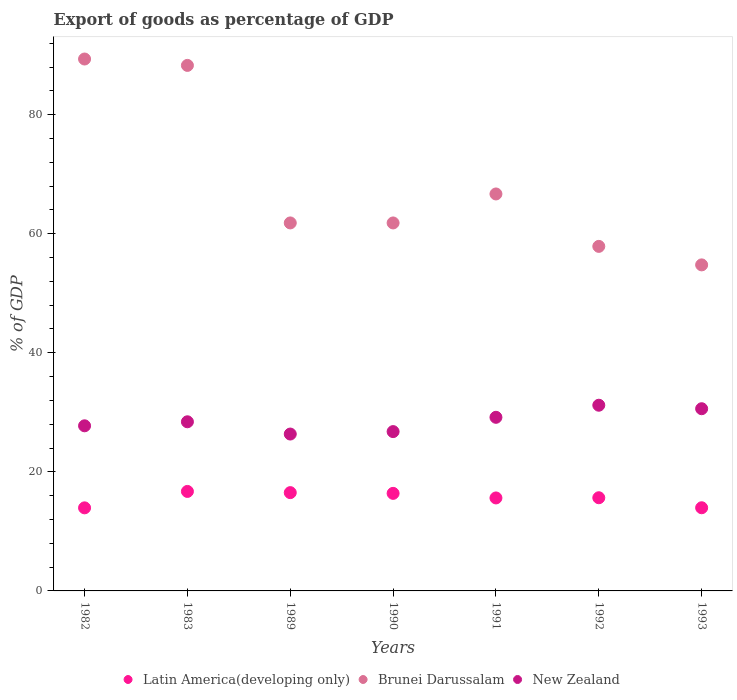Is the number of dotlines equal to the number of legend labels?
Make the answer very short. Yes. What is the export of goods as percentage of GDP in Latin America(developing only) in 1991?
Offer a very short reply. 15.62. Across all years, what is the maximum export of goods as percentage of GDP in New Zealand?
Make the answer very short. 31.19. Across all years, what is the minimum export of goods as percentage of GDP in Latin America(developing only)?
Offer a very short reply. 13.95. In which year was the export of goods as percentage of GDP in Latin America(developing only) maximum?
Provide a short and direct response. 1983. In which year was the export of goods as percentage of GDP in Latin America(developing only) minimum?
Give a very brief answer. 1982. What is the total export of goods as percentage of GDP in New Zealand in the graph?
Give a very brief answer. 200.21. What is the difference between the export of goods as percentage of GDP in Brunei Darussalam in 1989 and that in 1991?
Offer a very short reply. -4.87. What is the difference between the export of goods as percentage of GDP in New Zealand in 1989 and the export of goods as percentage of GDP in Latin America(developing only) in 1982?
Ensure brevity in your answer.  12.4. What is the average export of goods as percentage of GDP in New Zealand per year?
Give a very brief answer. 28.6. In the year 1992, what is the difference between the export of goods as percentage of GDP in Latin America(developing only) and export of goods as percentage of GDP in Brunei Darussalam?
Provide a succinct answer. -42.22. What is the ratio of the export of goods as percentage of GDP in Latin America(developing only) in 1983 to that in 1993?
Offer a very short reply. 1.2. Is the difference between the export of goods as percentage of GDP in Latin America(developing only) in 1983 and 1990 greater than the difference between the export of goods as percentage of GDP in Brunei Darussalam in 1983 and 1990?
Offer a very short reply. No. What is the difference between the highest and the second highest export of goods as percentage of GDP in New Zealand?
Make the answer very short. 0.59. What is the difference between the highest and the lowest export of goods as percentage of GDP in Brunei Darussalam?
Keep it short and to the point. 34.58. In how many years, is the export of goods as percentage of GDP in Brunei Darussalam greater than the average export of goods as percentage of GDP in Brunei Darussalam taken over all years?
Provide a succinct answer. 2. Is it the case that in every year, the sum of the export of goods as percentage of GDP in Latin America(developing only) and export of goods as percentage of GDP in Brunei Darussalam  is greater than the export of goods as percentage of GDP in New Zealand?
Ensure brevity in your answer.  Yes. Is the export of goods as percentage of GDP in Brunei Darussalam strictly greater than the export of goods as percentage of GDP in New Zealand over the years?
Your response must be concise. Yes. Is the export of goods as percentage of GDP in Latin America(developing only) strictly less than the export of goods as percentage of GDP in New Zealand over the years?
Offer a very short reply. Yes. Are the values on the major ticks of Y-axis written in scientific E-notation?
Your answer should be compact. No. Does the graph contain any zero values?
Provide a short and direct response. No. Does the graph contain grids?
Your answer should be very brief. No. How many legend labels are there?
Give a very brief answer. 3. What is the title of the graph?
Your answer should be very brief. Export of goods as percentage of GDP. Does "West Bank and Gaza" appear as one of the legend labels in the graph?
Provide a succinct answer. No. What is the label or title of the Y-axis?
Provide a succinct answer. % of GDP. What is the % of GDP of Latin America(developing only) in 1982?
Offer a very short reply. 13.95. What is the % of GDP in Brunei Darussalam in 1982?
Offer a terse response. 89.34. What is the % of GDP of New Zealand in 1982?
Your response must be concise. 27.73. What is the % of GDP of Latin America(developing only) in 1983?
Make the answer very short. 16.71. What is the % of GDP of Brunei Darussalam in 1983?
Offer a terse response. 88.27. What is the % of GDP of New Zealand in 1983?
Your answer should be compact. 28.41. What is the % of GDP of Latin America(developing only) in 1989?
Your answer should be very brief. 16.51. What is the % of GDP in Brunei Darussalam in 1989?
Your answer should be compact. 61.81. What is the % of GDP of New Zealand in 1989?
Offer a terse response. 26.35. What is the % of GDP of Latin America(developing only) in 1990?
Make the answer very short. 16.39. What is the % of GDP in Brunei Darussalam in 1990?
Ensure brevity in your answer.  61.81. What is the % of GDP in New Zealand in 1990?
Provide a succinct answer. 26.76. What is the % of GDP of Latin America(developing only) in 1991?
Your answer should be compact. 15.62. What is the % of GDP of Brunei Darussalam in 1991?
Make the answer very short. 66.68. What is the % of GDP of New Zealand in 1991?
Your answer should be compact. 29.16. What is the % of GDP in Latin America(developing only) in 1992?
Provide a short and direct response. 15.65. What is the % of GDP of Brunei Darussalam in 1992?
Make the answer very short. 57.87. What is the % of GDP of New Zealand in 1992?
Your answer should be very brief. 31.19. What is the % of GDP of Latin America(developing only) in 1993?
Offer a terse response. 13.97. What is the % of GDP in Brunei Darussalam in 1993?
Your response must be concise. 54.76. What is the % of GDP of New Zealand in 1993?
Give a very brief answer. 30.6. Across all years, what is the maximum % of GDP in Latin America(developing only)?
Your response must be concise. 16.71. Across all years, what is the maximum % of GDP in Brunei Darussalam?
Your answer should be very brief. 89.34. Across all years, what is the maximum % of GDP of New Zealand?
Keep it short and to the point. 31.19. Across all years, what is the minimum % of GDP of Latin America(developing only)?
Your answer should be very brief. 13.95. Across all years, what is the minimum % of GDP of Brunei Darussalam?
Your response must be concise. 54.76. Across all years, what is the minimum % of GDP of New Zealand?
Provide a succinct answer. 26.35. What is the total % of GDP of Latin America(developing only) in the graph?
Your answer should be compact. 108.8. What is the total % of GDP of Brunei Darussalam in the graph?
Make the answer very short. 480.55. What is the total % of GDP of New Zealand in the graph?
Your answer should be very brief. 200.21. What is the difference between the % of GDP in Latin America(developing only) in 1982 and that in 1983?
Your answer should be very brief. -2.76. What is the difference between the % of GDP in Brunei Darussalam in 1982 and that in 1983?
Give a very brief answer. 1.07. What is the difference between the % of GDP of New Zealand in 1982 and that in 1983?
Offer a very short reply. -0.68. What is the difference between the % of GDP in Latin America(developing only) in 1982 and that in 1989?
Keep it short and to the point. -2.56. What is the difference between the % of GDP of Brunei Darussalam in 1982 and that in 1989?
Your answer should be very brief. 27.53. What is the difference between the % of GDP of New Zealand in 1982 and that in 1989?
Offer a terse response. 1.38. What is the difference between the % of GDP in Latin America(developing only) in 1982 and that in 1990?
Offer a terse response. -2.43. What is the difference between the % of GDP in Brunei Darussalam in 1982 and that in 1990?
Your answer should be very brief. 27.53. What is the difference between the % of GDP of New Zealand in 1982 and that in 1990?
Keep it short and to the point. 0.97. What is the difference between the % of GDP of Latin America(developing only) in 1982 and that in 1991?
Your answer should be very brief. -1.66. What is the difference between the % of GDP of Brunei Darussalam in 1982 and that in 1991?
Make the answer very short. 22.67. What is the difference between the % of GDP in New Zealand in 1982 and that in 1991?
Provide a succinct answer. -1.43. What is the difference between the % of GDP of Latin America(developing only) in 1982 and that in 1992?
Provide a succinct answer. -1.7. What is the difference between the % of GDP of Brunei Darussalam in 1982 and that in 1992?
Make the answer very short. 31.47. What is the difference between the % of GDP in New Zealand in 1982 and that in 1992?
Make the answer very short. -3.46. What is the difference between the % of GDP in Latin America(developing only) in 1982 and that in 1993?
Provide a succinct answer. -0.01. What is the difference between the % of GDP of Brunei Darussalam in 1982 and that in 1993?
Provide a short and direct response. 34.58. What is the difference between the % of GDP of New Zealand in 1982 and that in 1993?
Offer a terse response. -2.87. What is the difference between the % of GDP of Latin America(developing only) in 1983 and that in 1989?
Make the answer very short. 0.2. What is the difference between the % of GDP of Brunei Darussalam in 1983 and that in 1989?
Provide a short and direct response. 26.46. What is the difference between the % of GDP of New Zealand in 1983 and that in 1989?
Give a very brief answer. 2.06. What is the difference between the % of GDP of Latin America(developing only) in 1983 and that in 1990?
Your answer should be very brief. 0.33. What is the difference between the % of GDP of Brunei Darussalam in 1983 and that in 1990?
Give a very brief answer. 26.46. What is the difference between the % of GDP in New Zealand in 1983 and that in 1990?
Offer a very short reply. 1.65. What is the difference between the % of GDP of Latin America(developing only) in 1983 and that in 1991?
Give a very brief answer. 1.09. What is the difference between the % of GDP in Brunei Darussalam in 1983 and that in 1991?
Your answer should be very brief. 21.59. What is the difference between the % of GDP in New Zealand in 1983 and that in 1991?
Offer a very short reply. -0.75. What is the difference between the % of GDP of Latin America(developing only) in 1983 and that in 1992?
Provide a short and direct response. 1.06. What is the difference between the % of GDP of Brunei Darussalam in 1983 and that in 1992?
Ensure brevity in your answer.  30.4. What is the difference between the % of GDP of New Zealand in 1983 and that in 1992?
Offer a very short reply. -2.78. What is the difference between the % of GDP in Latin America(developing only) in 1983 and that in 1993?
Provide a succinct answer. 2.74. What is the difference between the % of GDP of Brunei Darussalam in 1983 and that in 1993?
Offer a very short reply. 33.51. What is the difference between the % of GDP in New Zealand in 1983 and that in 1993?
Give a very brief answer. -2.19. What is the difference between the % of GDP of Latin America(developing only) in 1989 and that in 1990?
Ensure brevity in your answer.  0.12. What is the difference between the % of GDP of Brunei Darussalam in 1989 and that in 1990?
Give a very brief answer. 0. What is the difference between the % of GDP of New Zealand in 1989 and that in 1990?
Make the answer very short. -0.41. What is the difference between the % of GDP of Latin America(developing only) in 1989 and that in 1991?
Your answer should be compact. 0.89. What is the difference between the % of GDP in Brunei Darussalam in 1989 and that in 1991?
Your response must be concise. -4.87. What is the difference between the % of GDP of New Zealand in 1989 and that in 1991?
Offer a very short reply. -2.81. What is the difference between the % of GDP in Latin America(developing only) in 1989 and that in 1992?
Offer a very short reply. 0.86. What is the difference between the % of GDP in Brunei Darussalam in 1989 and that in 1992?
Give a very brief answer. 3.94. What is the difference between the % of GDP of New Zealand in 1989 and that in 1992?
Make the answer very short. -4.84. What is the difference between the % of GDP in Latin America(developing only) in 1989 and that in 1993?
Give a very brief answer. 2.54. What is the difference between the % of GDP of Brunei Darussalam in 1989 and that in 1993?
Offer a very short reply. 7.05. What is the difference between the % of GDP in New Zealand in 1989 and that in 1993?
Give a very brief answer. -4.25. What is the difference between the % of GDP of Latin America(developing only) in 1990 and that in 1991?
Your answer should be very brief. 0.77. What is the difference between the % of GDP in Brunei Darussalam in 1990 and that in 1991?
Ensure brevity in your answer.  -4.87. What is the difference between the % of GDP of New Zealand in 1990 and that in 1991?
Ensure brevity in your answer.  -2.4. What is the difference between the % of GDP of Latin America(developing only) in 1990 and that in 1992?
Your response must be concise. 0.73. What is the difference between the % of GDP in Brunei Darussalam in 1990 and that in 1992?
Provide a succinct answer. 3.94. What is the difference between the % of GDP of New Zealand in 1990 and that in 1992?
Provide a succinct answer. -4.43. What is the difference between the % of GDP in Latin America(developing only) in 1990 and that in 1993?
Your response must be concise. 2.42. What is the difference between the % of GDP in Brunei Darussalam in 1990 and that in 1993?
Your answer should be compact. 7.05. What is the difference between the % of GDP of New Zealand in 1990 and that in 1993?
Provide a short and direct response. -3.84. What is the difference between the % of GDP of Latin America(developing only) in 1991 and that in 1992?
Your response must be concise. -0.03. What is the difference between the % of GDP in Brunei Darussalam in 1991 and that in 1992?
Your response must be concise. 8.8. What is the difference between the % of GDP of New Zealand in 1991 and that in 1992?
Keep it short and to the point. -2.03. What is the difference between the % of GDP in Latin America(developing only) in 1991 and that in 1993?
Your answer should be very brief. 1.65. What is the difference between the % of GDP of Brunei Darussalam in 1991 and that in 1993?
Offer a terse response. 11.91. What is the difference between the % of GDP of New Zealand in 1991 and that in 1993?
Give a very brief answer. -1.44. What is the difference between the % of GDP in Latin America(developing only) in 1992 and that in 1993?
Offer a terse response. 1.68. What is the difference between the % of GDP in Brunei Darussalam in 1992 and that in 1993?
Your answer should be very brief. 3.11. What is the difference between the % of GDP in New Zealand in 1992 and that in 1993?
Provide a short and direct response. 0.59. What is the difference between the % of GDP of Latin America(developing only) in 1982 and the % of GDP of Brunei Darussalam in 1983?
Provide a succinct answer. -74.32. What is the difference between the % of GDP in Latin America(developing only) in 1982 and the % of GDP in New Zealand in 1983?
Your response must be concise. -14.46. What is the difference between the % of GDP of Brunei Darussalam in 1982 and the % of GDP of New Zealand in 1983?
Ensure brevity in your answer.  60.93. What is the difference between the % of GDP of Latin America(developing only) in 1982 and the % of GDP of Brunei Darussalam in 1989?
Your answer should be compact. -47.86. What is the difference between the % of GDP of Latin America(developing only) in 1982 and the % of GDP of New Zealand in 1989?
Provide a succinct answer. -12.4. What is the difference between the % of GDP of Brunei Darussalam in 1982 and the % of GDP of New Zealand in 1989?
Your answer should be compact. 62.99. What is the difference between the % of GDP of Latin America(developing only) in 1982 and the % of GDP of Brunei Darussalam in 1990?
Offer a terse response. -47.86. What is the difference between the % of GDP in Latin America(developing only) in 1982 and the % of GDP in New Zealand in 1990?
Ensure brevity in your answer.  -12.81. What is the difference between the % of GDP of Brunei Darussalam in 1982 and the % of GDP of New Zealand in 1990?
Your answer should be compact. 62.58. What is the difference between the % of GDP of Latin America(developing only) in 1982 and the % of GDP of Brunei Darussalam in 1991?
Your answer should be very brief. -52.72. What is the difference between the % of GDP in Latin America(developing only) in 1982 and the % of GDP in New Zealand in 1991?
Your answer should be compact. -15.21. What is the difference between the % of GDP of Brunei Darussalam in 1982 and the % of GDP of New Zealand in 1991?
Your response must be concise. 60.18. What is the difference between the % of GDP of Latin America(developing only) in 1982 and the % of GDP of Brunei Darussalam in 1992?
Make the answer very short. -43.92. What is the difference between the % of GDP of Latin America(developing only) in 1982 and the % of GDP of New Zealand in 1992?
Ensure brevity in your answer.  -17.24. What is the difference between the % of GDP of Brunei Darussalam in 1982 and the % of GDP of New Zealand in 1992?
Your answer should be very brief. 58.15. What is the difference between the % of GDP of Latin America(developing only) in 1982 and the % of GDP of Brunei Darussalam in 1993?
Offer a very short reply. -40.81. What is the difference between the % of GDP in Latin America(developing only) in 1982 and the % of GDP in New Zealand in 1993?
Provide a succinct answer. -16.65. What is the difference between the % of GDP of Brunei Darussalam in 1982 and the % of GDP of New Zealand in 1993?
Make the answer very short. 58.74. What is the difference between the % of GDP of Latin America(developing only) in 1983 and the % of GDP of Brunei Darussalam in 1989?
Provide a succinct answer. -45.1. What is the difference between the % of GDP of Latin America(developing only) in 1983 and the % of GDP of New Zealand in 1989?
Offer a very short reply. -9.64. What is the difference between the % of GDP in Brunei Darussalam in 1983 and the % of GDP in New Zealand in 1989?
Make the answer very short. 61.92. What is the difference between the % of GDP in Latin America(developing only) in 1983 and the % of GDP in Brunei Darussalam in 1990?
Offer a very short reply. -45.1. What is the difference between the % of GDP of Latin America(developing only) in 1983 and the % of GDP of New Zealand in 1990?
Make the answer very short. -10.05. What is the difference between the % of GDP of Brunei Darussalam in 1983 and the % of GDP of New Zealand in 1990?
Offer a terse response. 61.51. What is the difference between the % of GDP in Latin America(developing only) in 1983 and the % of GDP in Brunei Darussalam in 1991?
Make the answer very short. -49.97. What is the difference between the % of GDP in Latin America(developing only) in 1983 and the % of GDP in New Zealand in 1991?
Your answer should be very brief. -12.45. What is the difference between the % of GDP in Brunei Darussalam in 1983 and the % of GDP in New Zealand in 1991?
Offer a very short reply. 59.11. What is the difference between the % of GDP in Latin America(developing only) in 1983 and the % of GDP in Brunei Darussalam in 1992?
Your answer should be compact. -41.16. What is the difference between the % of GDP in Latin America(developing only) in 1983 and the % of GDP in New Zealand in 1992?
Provide a succinct answer. -14.48. What is the difference between the % of GDP of Brunei Darussalam in 1983 and the % of GDP of New Zealand in 1992?
Keep it short and to the point. 57.08. What is the difference between the % of GDP in Latin America(developing only) in 1983 and the % of GDP in Brunei Darussalam in 1993?
Make the answer very short. -38.05. What is the difference between the % of GDP of Latin America(developing only) in 1983 and the % of GDP of New Zealand in 1993?
Ensure brevity in your answer.  -13.89. What is the difference between the % of GDP of Brunei Darussalam in 1983 and the % of GDP of New Zealand in 1993?
Your answer should be very brief. 57.67. What is the difference between the % of GDP in Latin America(developing only) in 1989 and the % of GDP in Brunei Darussalam in 1990?
Offer a very short reply. -45.3. What is the difference between the % of GDP in Latin America(developing only) in 1989 and the % of GDP in New Zealand in 1990?
Provide a succinct answer. -10.25. What is the difference between the % of GDP in Brunei Darussalam in 1989 and the % of GDP in New Zealand in 1990?
Provide a succinct answer. 35.05. What is the difference between the % of GDP of Latin America(developing only) in 1989 and the % of GDP of Brunei Darussalam in 1991?
Provide a short and direct response. -50.17. What is the difference between the % of GDP of Latin America(developing only) in 1989 and the % of GDP of New Zealand in 1991?
Your response must be concise. -12.65. What is the difference between the % of GDP of Brunei Darussalam in 1989 and the % of GDP of New Zealand in 1991?
Make the answer very short. 32.65. What is the difference between the % of GDP of Latin America(developing only) in 1989 and the % of GDP of Brunei Darussalam in 1992?
Offer a terse response. -41.36. What is the difference between the % of GDP in Latin America(developing only) in 1989 and the % of GDP in New Zealand in 1992?
Your answer should be very brief. -14.68. What is the difference between the % of GDP of Brunei Darussalam in 1989 and the % of GDP of New Zealand in 1992?
Offer a very short reply. 30.62. What is the difference between the % of GDP of Latin America(developing only) in 1989 and the % of GDP of Brunei Darussalam in 1993?
Ensure brevity in your answer.  -38.25. What is the difference between the % of GDP in Latin America(developing only) in 1989 and the % of GDP in New Zealand in 1993?
Your response must be concise. -14.09. What is the difference between the % of GDP of Brunei Darussalam in 1989 and the % of GDP of New Zealand in 1993?
Ensure brevity in your answer.  31.21. What is the difference between the % of GDP in Latin America(developing only) in 1990 and the % of GDP in Brunei Darussalam in 1991?
Give a very brief answer. -50.29. What is the difference between the % of GDP of Latin America(developing only) in 1990 and the % of GDP of New Zealand in 1991?
Offer a very short reply. -12.78. What is the difference between the % of GDP of Brunei Darussalam in 1990 and the % of GDP of New Zealand in 1991?
Your answer should be compact. 32.65. What is the difference between the % of GDP in Latin America(developing only) in 1990 and the % of GDP in Brunei Darussalam in 1992?
Give a very brief answer. -41.49. What is the difference between the % of GDP of Latin America(developing only) in 1990 and the % of GDP of New Zealand in 1992?
Your answer should be compact. -14.81. What is the difference between the % of GDP of Brunei Darussalam in 1990 and the % of GDP of New Zealand in 1992?
Your answer should be compact. 30.62. What is the difference between the % of GDP of Latin America(developing only) in 1990 and the % of GDP of Brunei Darussalam in 1993?
Provide a succinct answer. -38.38. What is the difference between the % of GDP of Latin America(developing only) in 1990 and the % of GDP of New Zealand in 1993?
Ensure brevity in your answer.  -14.22. What is the difference between the % of GDP of Brunei Darussalam in 1990 and the % of GDP of New Zealand in 1993?
Ensure brevity in your answer.  31.21. What is the difference between the % of GDP of Latin America(developing only) in 1991 and the % of GDP of Brunei Darussalam in 1992?
Offer a very short reply. -42.25. What is the difference between the % of GDP of Latin America(developing only) in 1991 and the % of GDP of New Zealand in 1992?
Provide a succinct answer. -15.57. What is the difference between the % of GDP of Brunei Darussalam in 1991 and the % of GDP of New Zealand in 1992?
Your response must be concise. 35.49. What is the difference between the % of GDP of Latin America(developing only) in 1991 and the % of GDP of Brunei Darussalam in 1993?
Provide a short and direct response. -39.15. What is the difference between the % of GDP in Latin America(developing only) in 1991 and the % of GDP in New Zealand in 1993?
Keep it short and to the point. -14.99. What is the difference between the % of GDP of Brunei Darussalam in 1991 and the % of GDP of New Zealand in 1993?
Provide a short and direct response. 36.07. What is the difference between the % of GDP of Latin America(developing only) in 1992 and the % of GDP of Brunei Darussalam in 1993?
Provide a short and direct response. -39.11. What is the difference between the % of GDP in Latin America(developing only) in 1992 and the % of GDP in New Zealand in 1993?
Your response must be concise. -14.95. What is the difference between the % of GDP in Brunei Darussalam in 1992 and the % of GDP in New Zealand in 1993?
Provide a short and direct response. 27.27. What is the average % of GDP in Latin America(developing only) per year?
Ensure brevity in your answer.  15.54. What is the average % of GDP in Brunei Darussalam per year?
Keep it short and to the point. 68.65. What is the average % of GDP in New Zealand per year?
Provide a succinct answer. 28.6. In the year 1982, what is the difference between the % of GDP of Latin America(developing only) and % of GDP of Brunei Darussalam?
Your answer should be compact. -75.39. In the year 1982, what is the difference between the % of GDP of Latin America(developing only) and % of GDP of New Zealand?
Offer a very short reply. -13.78. In the year 1982, what is the difference between the % of GDP of Brunei Darussalam and % of GDP of New Zealand?
Your answer should be very brief. 61.61. In the year 1983, what is the difference between the % of GDP in Latin America(developing only) and % of GDP in Brunei Darussalam?
Provide a short and direct response. -71.56. In the year 1983, what is the difference between the % of GDP of Latin America(developing only) and % of GDP of New Zealand?
Offer a very short reply. -11.7. In the year 1983, what is the difference between the % of GDP in Brunei Darussalam and % of GDP in New Zealand?
Your answer should be very brief. 59.86. In the year 1989, what is the difference between the % of GDP in Latin America(developing only) and % of GDP in Brunei Darussalam?
Your answer should be compact. -45.3. In the year 1989, what is the difference between the % of GDP in Latin America(developing only) and % of GDP in New Zealand?
Your response must be concise. -9.84. In the year 1989, what is the difference between the % of GDP in Brunei Darussalam and % of GDP in New Zealand?
Ensure brevity in your answer.  35.46. In the year 1990, what is the difference between the % of GDP in Latin America(developing only) and % of GDP in Brunei Darussalam?
Provide a short and direct response. -45.42. In the year 1990, what is the difference between the % of GDP in Latin America(developing only) and % of GDP in New Zealand?
Your response must be concise. -10.38. In the year 1990, what is the difference between the % of GDP in Brunei Darussalam and % of GDP in New Zealand?
Your response must be concise. 35.05. In the year 1991, what is the difference between the % of GDP in Latin America(developing only) and % of GDP in Brunei Darussalam?
Give a very brief answer. -51.06. In the year 1991, what is the difference between the % of GDP in Latin America(developing only) and % of GDP in New Zealand?
Your answer should be very brief. -13.54. In the year 1991, what is the difference between the % of GDP in Brunei Darussalam and % of GDP in New Zealand?
Keep it short and to the point. 37.52. In the year 1992, what is the difference between the % of GDP of Latin America(developing only) and % of GDP of Brunei Darussalam?
Give a very brief answer. -42.22. In the year 1992, what is the difference between the % of GDP in Latin America(developing only) and % of GDP in New Zealand?
Keep it short and to the point. -15.54. In the year 1992, what is the difference between the % of GDP in Brunei Darussalam and % of GDP in New Zealand?
Offer a terse response. 26.68. In the year 1993, what is the difference between the % of GDP of Latin America(developing only) and % of GDP of Brunei Darussalam?
Make the answer very short. -40.8. In the year 1993, what is the difference between the % of GDP of Latin America(developing only) and % of GDP of New Zealand?
Provide a succinct answer. -16.64. In the year 1993, what is the difference between the % of GDP of Brunei Darussalam and % of GDP of New Zealand?
Offer a very short reply. 24.16. What is the ratio of the % of GDP in Latin America(developing only) in 1982 to that in 1983?
Make the answer very short. 0.83. What is the ratio of the % of GDP in Brunei Darussalam in 1982 to that in 1983?
Keep it short and to the point. 1.01. What is the ratio of the % of GDP in New Zealand in 1982 to that in 1983?
Offer a terse response. 0.98. What is the ratio of the % of GDP of Latin America(developing only) in 1982 to that in 1989?
Ensure brevity in your answer.  0.85. What is the ratio of the % of GDP in Brunei Darussalam in 1982 to that in 1989?
Your response must be concise. 1.45. What is the ratio of the % of GDP of New Zealand in 1982 to that in 1989?
Your response must be concise. 1.05. What is the ratio of the % of GDP of Latin America(developing only) in 1982 to that in 1990?
Provide a succinct answer. 0.85. What is the ratio of the % of GDP in Brunei Darussalam in 1982 to that in 1990?
Your response must be concise. 1.45. What is the ratio of the % of GDP of New Zealand in 1982 to that in 1990?
Ensure brevity in your answer.  1.04. What is the ratio of the % of GDP of Latin America(developing only) in 1982 to that in 1991?
Make the answer very short. 0.89. What is the ratio of the % of GDP of Brunei Darussalam in 1982 to that in 1991?
Make the answer very short. 1.34. What is the ratio of the % of GDP of New Zealand in 1982 to that in 1991?
Your answer should be very brief. 0.95. What is the ratio of the % of GDP in Latin America(developing only) in 1982 to that in 1992?
Offer a terse response. 0.89. What is the ratio of the % of GDP in Brunei Darussalam in 1982 to that in 1992?
Your answer should be compact. 1.54. What is the ratio of the % of GDP in New Zealand in 1982 to that in 1992?
Make the answer very short. 0.89. What is the ratio of the % of GDP in Brunei Darussalam in 1982 to that in 1993?
Ensure brevity in your answer.  1.63. What is the ratio of the % of GDP in New Zealand in 1982 to that in 1993?
Your answer should be compact. 0.91. What is the ratio of the % of GDP of Latin America(developing only) in 1983 to that in 1989?
Your answer should be very brief. 1.01. What is the ratio of the % of GDP of Brunei Darussalam in 1983 to that in 1989?
Give a very brief answer. 1.43. What is the ratio of the % of GDP of New Zealand in 1983 to that in 1989?
Make the answer very short. 1.08. What is the ratio of the % of GDP of Latin America(developing only) in 1983 to that in 1990?
Your response must be concise. 1.02. What is the ratio of the % of GDP of Brunei Darussalam in 1983 to that in 1990?
Give a very brief answer. 1.43. What is the ratio of the % of GDP in New Zealand in 1983 to that in 1990?
Offer a very short reply. 1.06. What is the ratio of the % of GDP of Latin America(developing only) in 1983 to that in 1991?
Make the answer very short. 1.07. What is the ratio of the % of GDP of Brunei Darussalam in 1983 to that in 1991?
Give a very brief answer. 1.32. What is the ratio of the % of GDP in New Zealand in 1983 to that in 1991?
Your response must be concise. 0.97. What is the ratio of the % of GDP of Latin America(developing only) in 1983 to that in 1992?
Provide a short and direct response. 1.07. What is the ratio of the % of GDP in Brunei Darussalam in 1983 to that in 1992?
Your response must be concise. 1.53. What is the ratio of the % of GDP of New Zealand in 1983 to that in 1992?
Your answer should be compact. 0.91. What is the ratio of the % of GDP of Latin America(developing only) in 1983 to that in 1993?
Keep it short and to the point. 1.2. What is the ratio of the % of GDP of Brunei Darussalam in 1983 to that in 1993?
Your answer should be compact. 1.61. What is the ratio of the % of GDP of New Zealand in 1983 to that in 1993?
Make the answer very short. 0.93. What is the ratio of the % of GDP of Latin America(developing only) in 1989 to that in 1990?
Provide a short and direct response. 1.01. What is the ratio of the % of GDP in Brunei Darussalam in 1989 to that in 1990?
Provide a succinct answer. 1. What is the ratio of the % of GDP in New Zealand in 1989 to that in 1990?
Your answer should be very brief. 0.98. What is the ratio of the % of GDP of Latin America(developing only) in 1989 to that in 1991?
Offer a terse response. 1.06. What is the ratio of the % of GDP in Brunei Darussalam in 1989 to that in 1991?
Ensure brevity in your answer.  0.93. What is the ratio of the % of GDP in New Zealand in 1989 to that in 1991?
Your answer should be very brief. 0.9. What is the ratio of the % of GDP in Latin America(developing only) in 1989 to that in 1992?
Offer a terse response. 1.05. What is the ratio of the % of GDP in Brunei Darussalam in 1989 to that in 1992?
Give a very brief answer. 1.07. What is the ratio of the % of GDP of New Zealand in 1989 to that in 1992?
Offer a terse response. 0.84. What is the ratio of the % of GDP of Latin America(developing only) in 1989 to that in 1993?
Your answer should be very brief. 1.18. What is the ratio of the % of GDP of Brunei Darussalam in 1989 to that in 1993?
Keep it short and to the point. 1.13. What is the ratio of the % of GDP of New Zealand in 1989 to that in 1993?
Make the answer very short. 0.86. What is the ratio of the % of GDP of Latin America(developing only) in 1990 to that in 1991?
Offer a terse response. 1.05. What is the ratio of the % of GDP of Brunei Darussalam in 1990 to that in 1991?
Your answer should be compact. 0.93. What is the ratio of the % of GDP in New Zealand in 1990 to that in 1991?
Make the answer very short. 0.92. What is the ratio of the % of GDP of Latin America(developing only) in 1990 to that in 1992?
Ensure brevity in your answer.  1.05. What is the ratio of the % of GDP of Brunei Darussalam in 1990 to that in 1992?
Your answer should be very brief. 1.07. What is the ratio of the % of GDP of New Zealand in 1990 to that in 1992?
Your response must be concise. 0.86. What is the ratio of the % of GDP in Latin America(developing only) in 1990 to that in 1993?
Your answer should be very brief. 1.17. What is the ratio of the % of GDP of Brunei Darussalam in 1990 to that in 1993?
Offer a terse response. 1.13. What is the ratio of the % of GDP of New Zealand in 1990 to that in 1993?
Make the answer very short. 0.87. What is the ratio of the % of GDP of Brunei Darussalam in 1991 to that in 1992?
Offer a very short reply. 1.15. What is the ratio of the % of GDP in New Zealand in 1991 to that in 1992?
Your answer should be very brief. 0.93. What is the ratio of the % of GDP in Latin America(developing only) in 1991 to that in 1993?
Offer a very short reply. 1.12. What is the ratio of the % of GDP of Brunei Darussalam in 1991 to that in 1993?
Your answer should be compact. 1.22. What is the ratio of the % of GDP in New Zealand in 1991 to that in 1993?
Your response must be concise. 0.95. What is the ratio of the % of GDP of Latin America(developing only) in 1992 to that in 1993?
Your answer should be compact. 1.12. What is the ratio of the % of GDP in Brunei Darussalam in 1992 to that in 1993?
Your answer should be very brief. 1.06. What is the ratio of the % of GDP of New Zealand in 1992 to that in 1993?
Your answer should be very brief. 1.02. What is the difference between the highest and the second highest % of GDP of Latin America(developing only)?
Your answer should be compact. 0.2. What is the difference between the highest and the second highest % of GDP in Brunei Darussalam?
Your answer should be very brief. 1.07. What is the difference between the highest and the second highest % of GDP of New Zealand?
Provide a short and direct response. 0.59. What is the difference between the highest and the lowest % of GDP in Latin America(developing only)?
Ensure brevity in your answer.  2.76. What is the difference between the highest and the lowest % of GDP in Brunei Darussalam?
Provide a short and direct response. 34.58. What is the difference between the highest and the lowest % of GDP of New Zealand?
Provide a short and direct response. 4.84. 